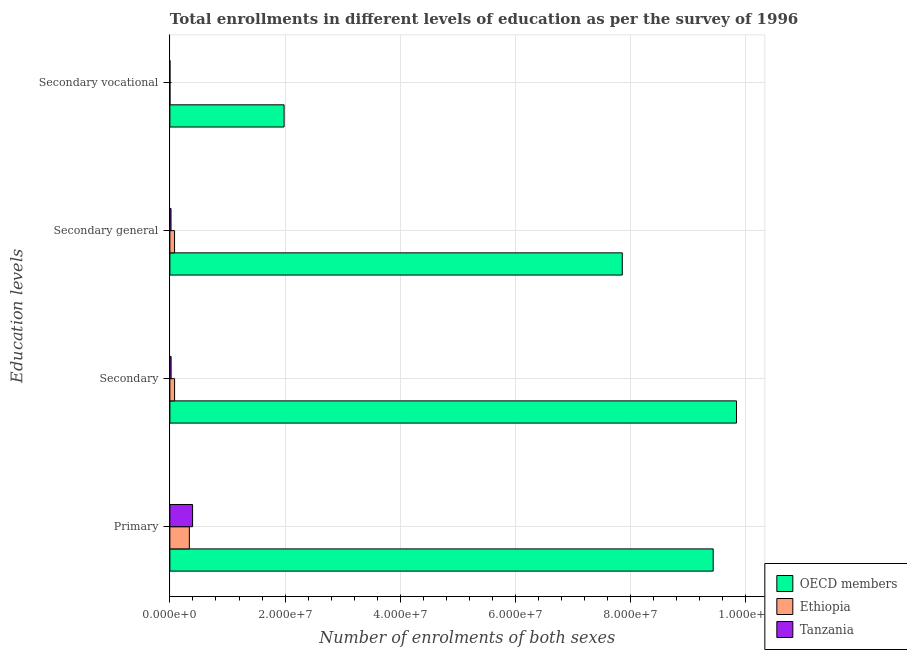How many different coloured bars are there?
Your answer should be very brief. 3. Are the number of bars on each tick of the Y-axis equal?
Offer a terse response. Yes. How many bars are there on the 2nd tick from the bottom?
Provide a succinct answer. 3. What is the label of the 1st group of bars from the top?
Your response must be concise. Secondary vocational. What is the number of enrolments in secondary education in OECD members?
Offer a very short reply. 9.84e+07. Across all countries, what is the maximum number of enrolments in secondary general education?
Offer a terse response. 7.85e+07. Across all countries, what is the minimum number of enrolments in secondary vocational education?
Give a very brief answer. 8638. In which country was the number of enrolments in secondary education minimum?
Your response must be concise. Tanzania. What is the total number of enrolments in secondary general education in the graph?
Your answer should be compact. 7.95e+07. What is the difference between the number of enrolments in primary education in Ethiopia and that in OECD members?
Your answer should be compact. -9.09e+07. What is the difference between the number of enrolments in secondary education in Tanzania and the number of enrolments in secondary general education in Ethiopia?
Your response must be concise. -5.97e+05. What is the average number of enrolments in secondary education per country?
Your answer should be very brief. 3.31e+07. What is the difference between the number of enrolments in primary education and number of enrolments in secondary general education in Ethiopia?
Make the answer very short. 2.57e+06. What is the ratio of the number of enrolments in secondary vocational education in Tanzania to that in OECD members?
Ensure brevity in your answer.  0. Is the difference between the number of enrolments in secondary general education in OECD members and Tanzania greater than the difference between the number of enrolments in primary education in OECD members and Tanzania?
Keep it short and to the point. No. What is the difference between the highest and the second highest number of enrolments in secondary education?
Provide a succinct answer. 9.75e+07. What is the difference between the highest and the lowest number of enrolments in primary education?
Your response must be concise. 9.09e+07. Is the sum of the number of enrolments in primary education in Tanzania and Ethiopia greater than the maximum number of enrolments in secondary general education across all countries?
Ensure brevity in your answer.  No. What does the 2nd bar from the top in Secondary represents?
Ensure brevity in your answer.  Ethiopia. What does the 2nd bar from the bottom in Secondary represents?
Your answer should be compact. Ethiopia. Are the values on the major ticks of X-axis written in scientific E-notation?
Provide a short and direct response. Yes. Does the graph contain any zero values?
Ensure brevity in your answer.  No. Does the graph contain grids?
Your answer should be very brief. Yes. How many legend labels are there?
Provide a succinct answer. 3. How are the legend labels stacked?
Provide a succinct answer. Vertical. What is the title of the graph?
Your response must be concise. Total enrollments in different levels of education as per the survey of 1996. Does "Ecuador" appear as one of the legend labels in the graph?
Your answer should be very brief. No. What is the label or title of the X-axis?
Keep it short and to the point. Number of enrolments of both sexes. What is the label or title of the Y-axis?
Your answer should be very brief. Education levels. What is the Number of enrolments of both sexes in OECD members in Primary?
Provide a short and direct response. 9.43e+07. What is the Number of enrolments of both sexes in Ethiopia in Primary?
Provide a short and direct response. 3.38e+06. What is the Number of enrolments of both sexes in Tanzania in Primary?
Give a very brief answer. 3.94e+06. What is the Number of enrolments of both sexes in OECD members in Secondary?
Offer a very short reply. 9.84e+07. What is the Number of enrolments of both sexes in Ethiopia in Secondary?
Offer a very short reply. 8.19e+05. What is the Number of enrolments of both sexes of Tanzania in Secondary?
Make the answer very short. 2.13e+05. What is the Number of enrolments of both sexes of OECD members in Secondary general?
Your answer should be very brief. 7.85e+07. What is the Number of enrolments of both sexes of Ethiopia in Secondary general?
Your response must be concise. 8.11e+05. What is the Number of enrolments of both sexes of Tanzania in Secondary general?
Offer a terse response. 1.99e+05. What is the Number of enrolments of both sexes of OECD members in Secondary vocational?
Keep it short and to the point. 1.98e+07. What is the Number of enrolments of both sexes of Ethiopia in Secondary vocational?
Your answer should be compact. 8638. What is the Number of enrolments of both sexes of Tanzania in Secondary vocational?
Your answer should be compact. 1.26e+04. Across all Education levels, what is the maximum Number of enrolments of both sexes in OECD members?
Your answer should be compact. 9.84e+07. Across all Education levels, what is the maximum Number of enrolments of both sexes in Ethiopia?
Make the answer very short. 3.38e+06. Across all Education levels, what is the maximum Number of enrolments of both sexes in Tanzania?
Your answer should be compact. 3.94e+06. Across all Education levels, what is the minimum Number of enrolments of both sexes in OECD members?
Keep it short and to the point. 1.98e+07. Across all Education levels, what is the minimum Number of enrolments of both sexes in Ethiopia?
Ensure brevity in your answer.  8638. Across all Education levels, what is the minimum Number of enrolments of both sexes of Tanzania?
Offer a terse response. 1.26e+04. What is the total Number of enrolments of both sexes in OECD members in the graph?
Provide a short and direct response. 2.91e+08. What is the total Number of enrolments of both sexes of Ethiopia in the graph?
Keep it short and to the point. 5.02e+06. What is the total Number of enrolments of both sexes in Tanzania in the graph?
Your answer should be compact. 4.37e+06. What is the difference between the Number of enrolments of both sexes of OECD members in Primary and that in Secondary?
Offer a very short reply. -4.05e+06. What is the difference between the Number of enrolments of both sexes of Ethiopia in Primary and that in Secondary?
Your answer should be compact. 2.56e+06. What is the difference between the Number of enrolments of both sexes in Tanzania in Primary and that in Secondary?
Provide a succinct answer. 3.73e+06. What is the difference between the Number of enrolments of both sexes in OECD members in Primary and that in Secondary general?
Your response must be concise. 1.58e+07. What is the difference between the Number of enrolments of both sexes in Ethiopia in Primary and that in Secondary general?
Give a very brief answer. 2.57e+06. What is the difference between the Number of enrolments of both sexes in Tanzania in Primary and that in Secondary general?
Your answer should be compact. 3.74e+06. What is the difference between the Number of enrolments of both sexes of OECD members in Primary and that in Secondary vocational?
Offer a very short reply. 7.45e+07. What is the difference between the Number of enrolments of both sexes of Ethiopia in Primary and that in Secondary vocational?
Provide a short and direct response. 3.37e+06. What is the difference between the Number of enrolments of both sexes in Tanzania in Primary and that in Secondary vocational?
Offer a very short reply. 3.93e+06. What is the difference between the Number of enrolments of both sexes in OECD members in Secondary and that in Secondary general?
Give a very brief answer. 1.98e+07. What is the difference between the Number of enrolments of both sexes in Ethiopia in Secondary and that in Secondary general?
Your answer should be compact. 8638. What is the difference between the Number of enrolments of both sexes in Tanzania in Secondary and that in Secondary general?
Offer a terse response. 1.43e+04. What is the difference between the Number of enrolments of both sexes in OECD members in Secondary and that in Secondary vocational?
Ensure brevity in your answer.  7.85e+07. What is the difference between the Number of enrolments of both sexes in Ethiopia in Secondary and that in Secondary vocational?
Offer a terse response. 8.11e+05. What is the difference between the Number of enrolments of both sexes of Tanzania in Secondary and that in Secondary vocational?
Your response must be concise. 2.01e+05. What is the difference between the Number of enrolments of both sexes of OECD members in Secondary general and that in Secondary vocational?
Keep it short and to the point. 5.87e+07. What is the difference between the Number of enrolments of both sexes of Ethiopia in Secondary general and that in Secondary vocational?
Your response must be concise. 8.02e+05. What is the difference between the Number of enrolments of both sexes of Tanzania in Secondary general and that in Secondary vocational?
Provide a short and direct response. 1.87e+05. What is the difference between the Number of enrolments of both sexes of OECD members in Primary and the Number of enrolments of both sexes of Ethiopia in Secondary?
Your response must be concise. 9.35e+07. What is the difference between the Number of enrolments of both sexes in OECD members in Primary and the Number of enrolments of both sexes in Tanzania in Secondary?
Your answer should be compact. 9.41e+07. What is the difference between the Number of enrolments of both sexes of Ethiopia in Primary and the Number of enrolments of both sexes of Tanzania in Secondary?
Your response must be concise. 3.17e+06. What is the difference between the Number of enrolments of both sexes of OECD members in Primary and the Number of enrolments of both sexes of Ethiopia in Secondary general?
Give a very brief answer. 9.35e+07. What is the difference between the Number of enrolments of both sexes in OECD members in Primary and the Number of enrolments of both sexes in Tanzania in Secondary general?
Your answer should be compact. 9.41e+07. What is the difference between the Number of enrolments of both sexes of Ethiopia in Primary and the Number of enrolments of both sexes of Tanzania in Secondary general?
Your answer should be very brief. 3.18e+06. What is the difference between the Number of enrolments of both sexes in OECD members in Primary and the Number of enrolments of both sexes in Ethiopia in Secondary vocational?
Make the answer very short. 9.43e+07. What is the difference between the Number of enrolments of both sexes of OECD members in Primary and the Number of enrolments of both sexes of Tanzania in Secondary vocational?
Provide a succinct answer. 9.43e+07. What is the difference between the Number of enrolments of both sexes of Ethiopia in Primary and the Number of enrolments of both sexes of Tanzania in Secondary vocational?
Give a very brief answer. 3.37e+06. What is the difference between the Number of enrolments of both sexes in OECD members in Secondary and the Number of enrolments of both sexes in Ethiopia in Secondary general?
Offer a terse response. 9.76e+07. What is the difference between the Number of enrolments of both sexes of OECD members in Secondary and the Number of enrolments of both sexes of Tanzania in Secondary general?
Ensure brevity in your answer.  9.82e+07. What is the difference between the Number of enrolments of both sexes in Ethiopia in Secondary and the Number of enrolments of both sexes in Tanzania in Secondary general?
Ensure brevity in your answer.  6.20e+05. What is the difference between the Number of enrolments of both sexes in OECD members in Secondary and the Number of enrolments of both sexes in Ethiopia in Secondary vocational?
Keep it short and to the point. 9.84e+07. What is the difference between the Number of enrolments of both sexes of OECD members in Secondary and the Number of enrolments of both sexes of Tanzania in Secondary vocational?
Provide a short and direct response. 9.84e+07. What is the difference between the Number of enrolments of both sexes of Ethiopia in Secondary and the Number of enrolments of both sexes of Tanzania in Secondary vocational?
Offer a terse response. 8.07e+05. What is the difference between the Number of enrolments of both sexes of OECD members in Secondary general and the Number of enrolments of both sexes of Ethiopia in Secondary vocational?
Provide a succinct answer. 7.85e+07. What is the difference between the Number of enrolments of both sexes of OECD members in Secondary general and the Number of enrolments of both sexes of Tanzania in Secondary vocational?
Your answer should be very brief. 7.85e+07. What is the difference between the Number of enrolments of both sexes of Ethiopia in Secondary general and the Number of enrolments of both sexes of Tanzania in Secondary vocational?
Offer a very short reply. 7.98e+05. What is the average Number of enrolments of both sexes of OECD members per Education levels?
Your answer should be very brief. 7.28e+07. What is the average Number of enrolments of both sexes in Ethiopia per Education levels?
Ensure brevity in your answer.  1.25e+06. What is the average Number of enrolments of both sexes in Tanzania per Education levels?
Make the answer very short. 1.09e+06. What is the difference between the Number of enrolments of both sexes in OECD members and Number of enrolments of both sexes in Ethiopia in Primary?
Ensure brevity in your answer.  9.09e+07. What is the difference between the Number of enrolments of both sexes of OECD members and Number of enrolments of both sexes of Tanzania in Primary?
Ensure brevity in your answer.  9.04e+07. What is the difference between the Number of enrolments of both sexes of Ethiopia and Number of enrolments of both sexes of Tanzania in Primary?
Make the answer very short. -5.63e+05. What is the difference between the Number of enrolments of both sexes of OECD members and Number of enrolments of both sexes of Ethiopia in Secondary?
Give a very brief answer. 9.75e+07. What is the difference between the Number of enrolments of both sexes of OECD members and Number of enrolments of both sexes of Tanzania in Secondary?
Your answer should be compact. 9.82e+07. What is the difference between the Number of enrolments of both sexes in Ethiopia and Number of enrolments of both sexes in Tanzania in Secondary?
Offer a very short reply. 6.06e+05. What is the difference between the Number of enrolments of both sexes in OECD members and Number of enrolments of both sexes in Ethiopia in Secondary general?
Ensure brevity in your answer.  7.77e+07. What is the difference between the Number of enrolments of both sexes in OECD members and Number of enrolments of both sexes in Tanzania in Secondary general?
Ensure brevity in your answer.  7.83e+07. What is the difference between the Number of enrolments of both sexes in Ethiopia and Number of enrolments of both sexes in Tanzania in Secondary general?
Make the answer very short. 6.12e+05. What is the difference between the Number of enrolments of both sexes of OECD members and Number of enrolments of both sexes of Ethiopia in Secondary vocational?
Your answer should be very brief. 1.98e+07. What is the difference between the Number of enrolments of both sexes of OECD members and Number of enrolments of both sexes of Tanzania in Secondary vocational?
Give a very brief answer. 1.98e+07. What is the difference between the Number of enrolments of both sexes in Ethiopia and Number of enrolments of both sexes in Tanzania in Secondary vocational?
Offer a terse response. -3933. What is the ratio of the Number of enrolments of both sexes in OECD members in Primary to that in Secondary?
Your answer should be very brief. 0.96. What is the ratio of the Number of enrolments of both sexes in Ethiopia in Primary to that in Secondary?
Your answer should be very brief. 4.13. What is the ratio of the Number of enrolments of both sexes in Tanzania in Primary to that in Secondary?
Offer a very short reply. 18.48. What is the ratio of the Number of enrolments of both sexes of OECD members in Primary to that in Secondary general?
Keep it short and to the point. 1.2. What is the ratio of the Number of enrolments of both sexes of Ethiopia in Primary to that in Secondary general?
Provide a succinct answer. 4.17. What is the ratio of the Number of enrolments of both sexes of Tanzania in Primary to that in Secondary general?
Ensure brevity in your answer.  19.8. What is the ratio of the Number of enrolments of both sexes of OECD members in Primary to that in Secondary vocational?
Offer a very short reply. 4.76. What is the ratio of the Number of enrolments of both sexes in Ethiopia in Primary to that in Secondary vocational?
Provide a short and direct response. 391.3. What is the ratio of the Number of enrolments of both sexes in Tanzania in Primary to that in Secondary vocational?
Provide a short and direct response. 313.65. What is the ratio of the Number of enrolments of both sexes in OECD members in Secondary to that in Secondary general?
Ensure brevity in your answer.  1.25. What is the ratio of the Number of enrolments of both sexes of Ethiopia in Secondary to that in Secondary general?
Keep it short and to the point. 1.01. What is the ratio of the Number of enrolments of both sexes of Tanzania in Secondary to that in Secondary general?
Ensure brevity in your answer.  1.07. What is the ratio of the Number of enrolments of both sexes of OECD members in Secondary to that in Secondary vocational?
Provide a succinct answer. 4.96. What is the ratio of the Number of enrolments of both sexes in Ethiopia in Secondary to that in Secondary vocational?
Ensure brevity in your answer.  94.84. What is the ratio of the Number of enrolments of both sexes of Tanzania in Secondary to that in Secondary vocational?
Offer a very short reply. 16.97. What is the ratio of the Number of enrolments of both sexes of OECD members in Secondary general to that in Secondary vocational?
Provide a succinct answer. 3.96. What is the ratio of the Number of enrolments of both sexes of Ethiopia in Secondary general to that in Secondary vocational?
Offer a terse response. 93.84. What is the ratio of the Number of enrolments of both sexes of Tanzania in Secondary general to that in Secondary vocational?
Provide a succinct answer. 15.84. What is the difference between the highest and the second highest Number of enrolments of both sexes of OECD members?
Offer a very short reply. 4.05e+06. What is the difference between the highest and the second highest Number of enrolments of both sexes of Ethiopia?
Keep it short and to the point. 2.56e+06. What is the difference between the highest and the second highest Number of enrolments of both sexes in Tanzania?
Your answer should be very brief. 3.73e+06. What is the difference between the highest and the lowest Number of enrolments of both sexes in OECD members?
Make the answer very short. 7.85e+07. What is the difference between the highest and the lowest Number of enrolments of both sexes in Ethiopia?
Provide a succinct answer. 3.37e+06. What is the difference between the highest and the lowest Number of enrolments of both sexes in Tanzania?
Provide a succinct answer. 3.93e+06. 